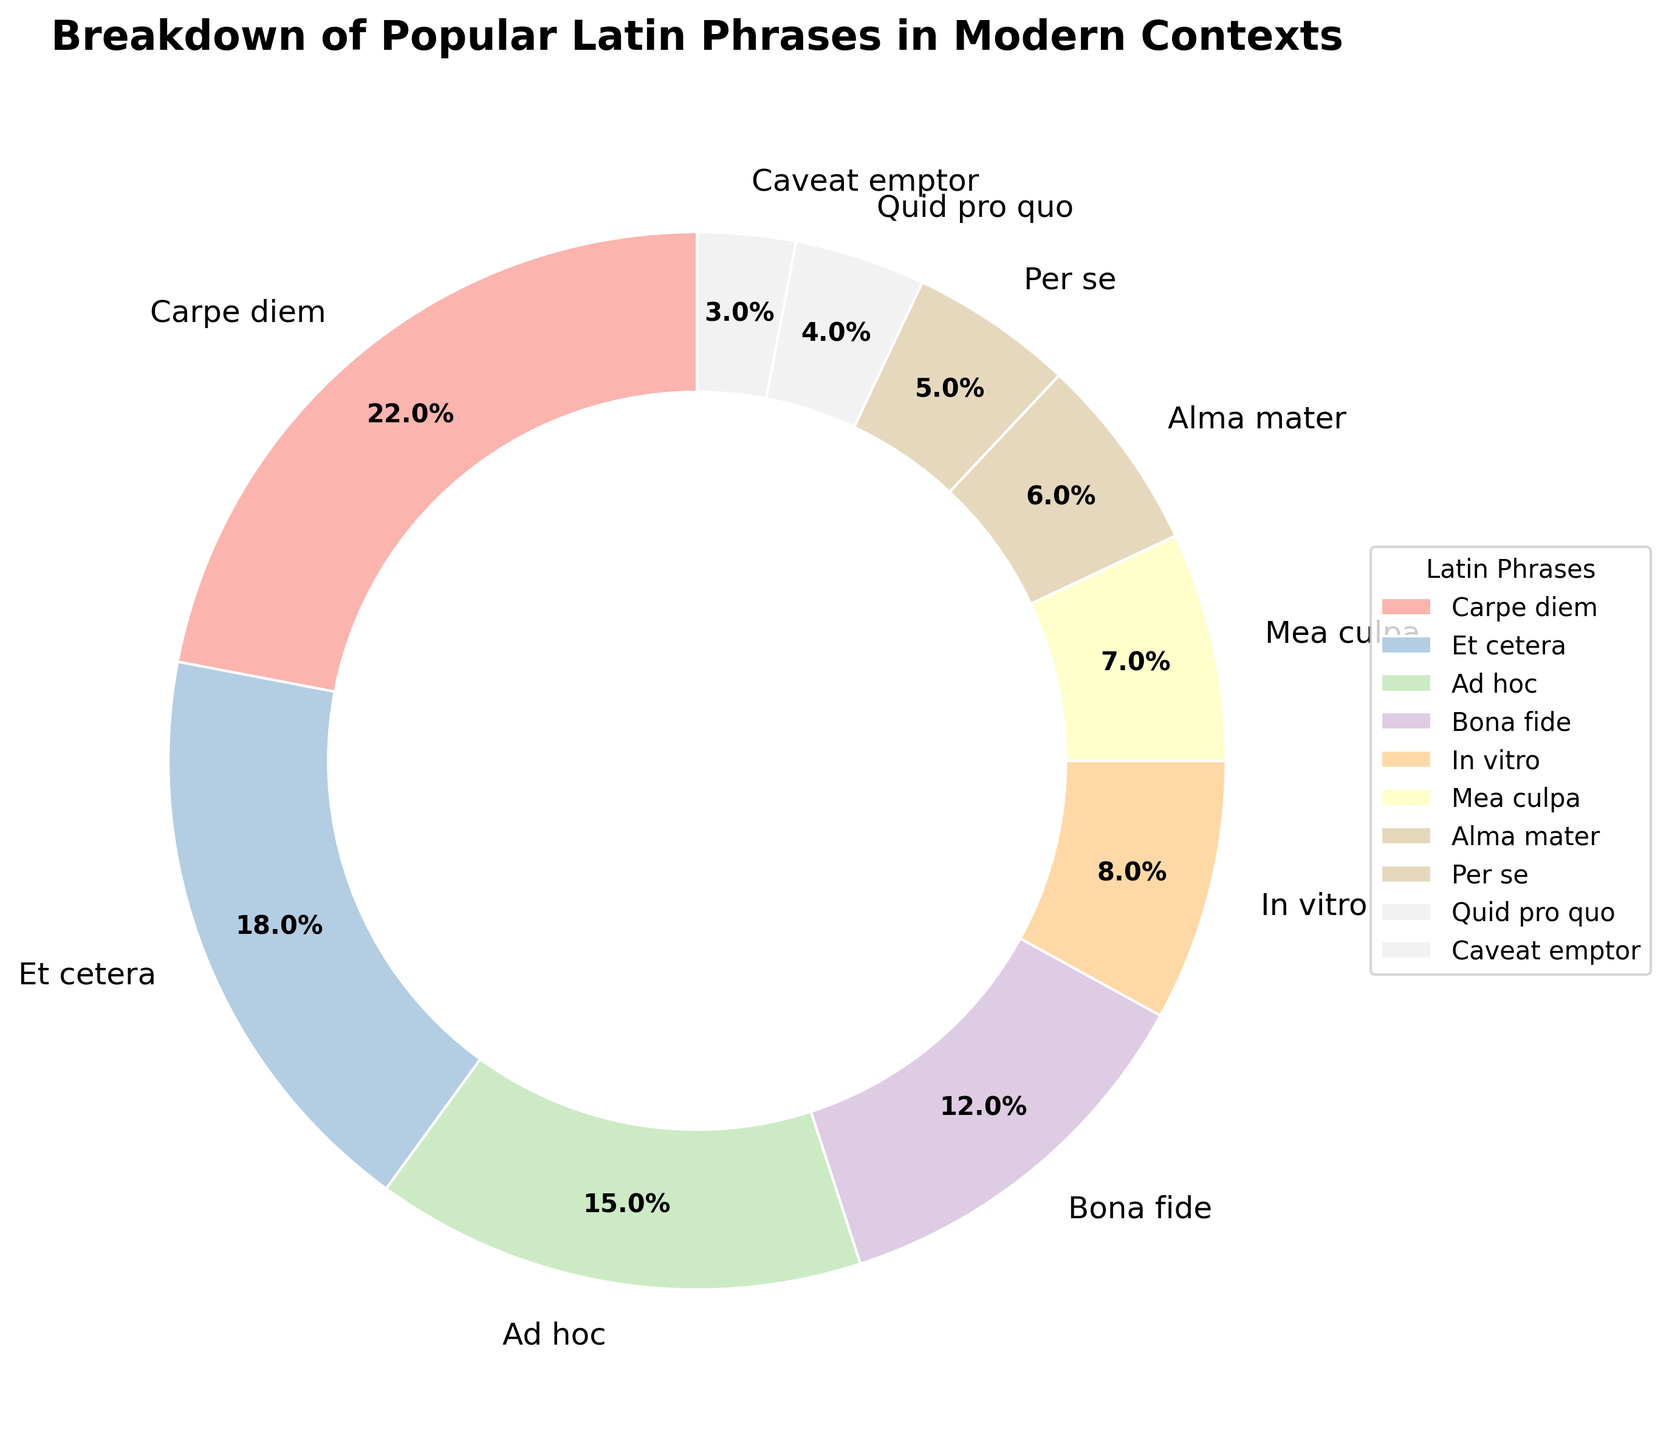what is the second most commonly used Latin phrase in modern contexts? The figure shows that "Et cetera" has a usage percentage of 18%, which is the second highest after "Carpe diem" at 22%
Answer: Et cetera Which Latin phrase has a smaller usage percentage: "In vitro" or "Mea culpa"? The figure shows that "In vitro" has a usage percentage of 8%, while "Mea culpa" has a usage percentage of 7%. 7% is smaller than 8%
Answer: Mea culpa How much more popular is "Carpe diem" compared to "Quid pro quo"? "Carpe diem" has a usage percentage of 22%, and "Quid pro quo" has 4%. To find the difference, subtract 4% from 22%
Answer: 18% What is the combined usage percentage of "Bona fide," "Alma mater," and "Caveat emptor"? Summing the usage percentages of "Bona fide" (12%), "Alma mater" (6%), and "Caveat emptor" (3%) gives 12% + 6% + 3% = 21%
Answer: 21% Which Latin phrase has the smallest usage percentage in the pie chart? The figure shows that "Caveat emptor" has the smallest usage percentage at 3%
Answer: Caveat emptor What is the difference in the usage percentage between "Per se" and "Quid pro quo"? "Per se" has a usage percentage of 5% and "Quid pro quo" has 4%. Subtract 4% from 5% to get the difference
Answer: 1% Are there more Latin phrases with a usage percentage above 15% or below 10%? The figure shows that there are 3 phrases above 15% ("Carpe diem," "Et cetera," "Ad hoc") and 5 phrases below 10%. So, there are more phrases below 10%
Answer: below 10% If "Carpe diem" were 2% less popular, which phrase would have the highest usage percentage? Subtracting 2% from "Carpe diem" gives 22% - 2% = 20%. "Et cetera," with 18%, would still be the second highest, so "Carpe diem" would still be the highest even if 2% less
Answer: Carpe diem Which two Latin phrases have a combined percentage of more than 25% but less than 30%? "Et cetera" (18%) and "Ad hoc" (15%) together sum to 18% + 15% = 33%, which is more than 25% but not less than 30%. "Et cetera" (18%) and "Bona fide" (12%) total 18% + 12% = 30%, which qualifies
Answer: Et cetera, Bona fide 